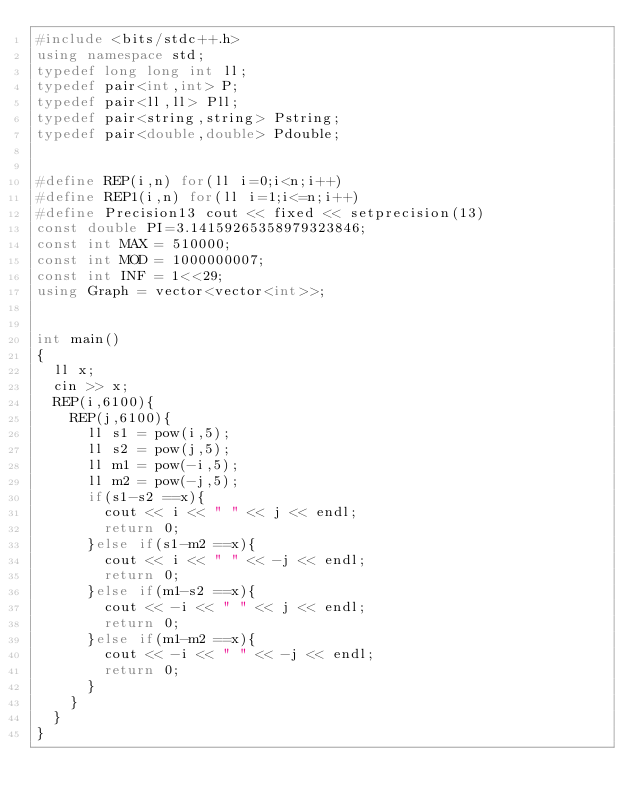Convert code to text. <code><loc_0><loc_0><loc_500><loc_500><_C++_>#include <bits/stdc++.h>
using namespace std;
typedef long long int ll;
typedef pair<int,int> P;
typedef pair<ll,ll> Pll;
typedef pair<string,string> Pstring;
typedef pair<double,double> Pdouble;


#define REP(i,n) for(ll i=0;i<n;i++)
#define REP1(i,n) for(ll i=1;i<=n;i++)
#define Precision13 cout << fixed << setprecision(13)
const double PI=3.14159265358979323846;
const int MAX = 510000;
const int MOD = 1000000007;
const int INF = 1<<29;
using Graph = vector<vector<int>>;


int main()
{
  ll x;
  cin >> x;
  REP(i,6100){
    REP(j,6100){
      ll s1 = pow(i,5);
      ll s2 = pow(j,5);
      ll m1 = pow(-i,5);
      ll m2 = pow(-j,5);
      if(s1-s2 ==x){
        cout << i << " " << j << endl;
        return 0;
      }else if(s1-m2 ==x){
        cout << i << " " << -j << endl;
        return 0;
      }else if(m1-s2 ==x){
        cout << -i << " " << j << endl;
        return 0;
      }else if(m1-m2 ==x){
        cout << -i << " " << -j << endl;
        return 0;
      }
    }
  }
}</code> 